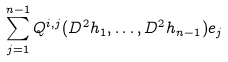<formula> <loc_0><loc_0><loc_500><loc_500>\sum _ { j = 1 } ^ { n - 1 } Q ^ { i , j } ( D ^ { 2 } h _ { 1 } , \dots , D ^ { 2 } h _ { n - 1 } ) e _ { j }</formula> 